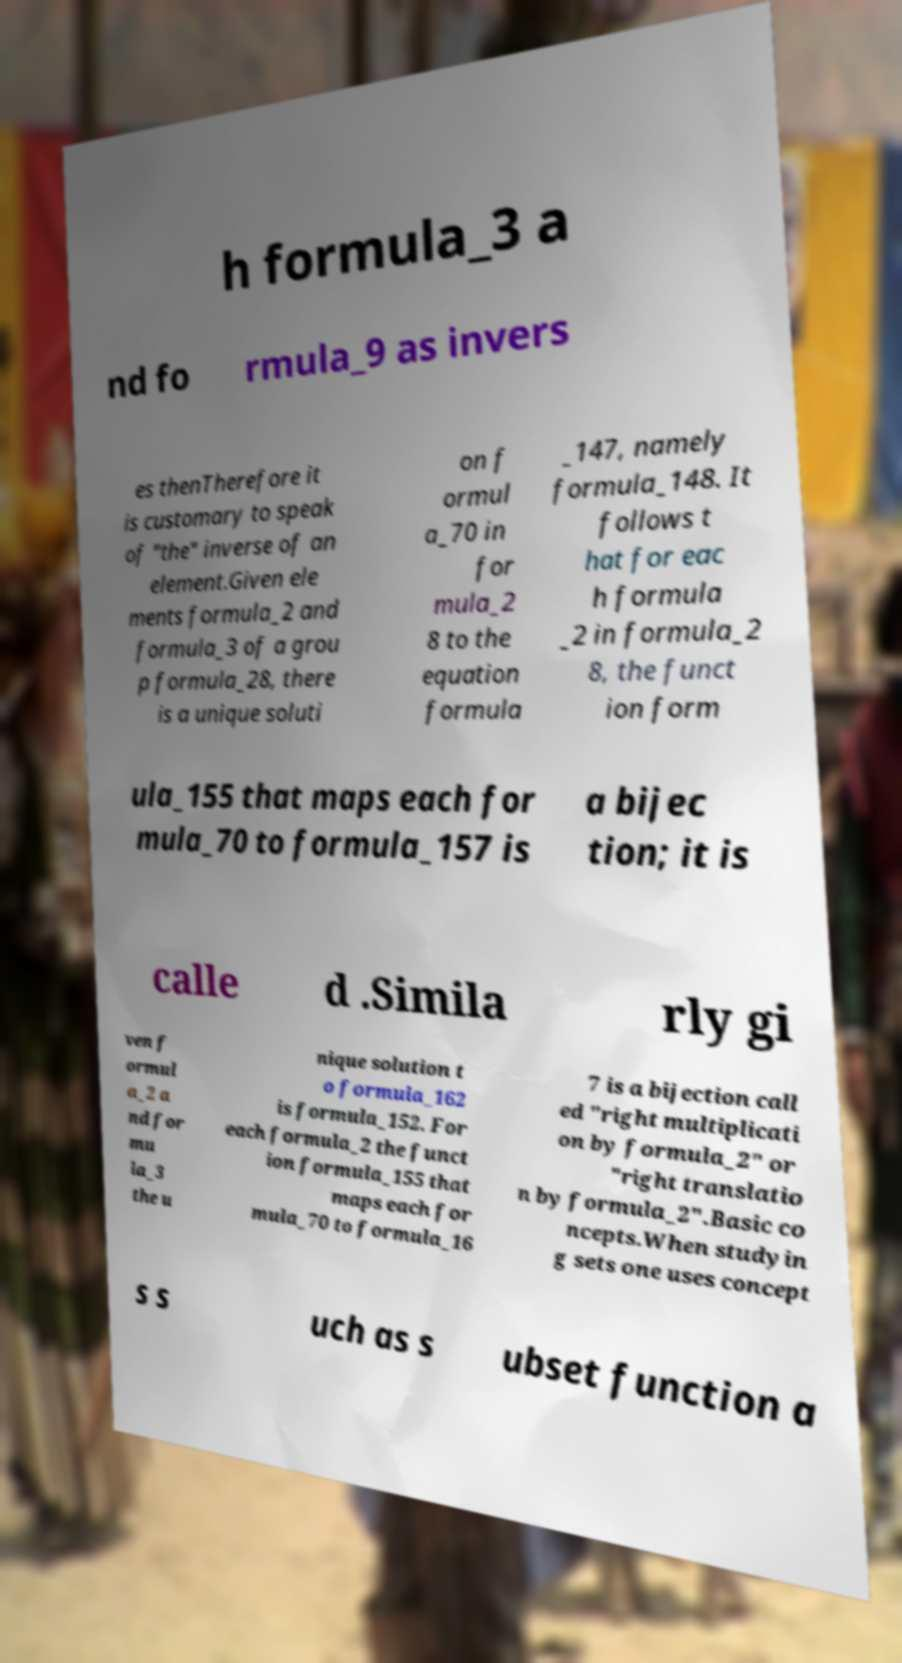I need the written content from this picture converted into text. Can you do that? h formula_3 a nd fo rmula_9 as invers es thenTherefore it is customary to speak of "the" inverse of an element.Given ele ments formula_2 and formula_3 of a grou p formula_28, there is a unique soluti on f ormul a_70 in for mula_2 8 to the equation formula _147, namely formula_148. It follows t hat for eac h formula _2 in formula_2 8, the funct ion form ula_155 that maps each for mula_70 to formula_157 is a bijec tion; it is calle d .Simila rly gi ven f ormul a_2 a nd for mu la_3 the u nique solution t o formula_162 is formula_152. For each formula_2 the funct ion formula_155 that maps each for mula_70 to formula_16 7 is a bijection call ed "right multiplicati on by formula_2" or "right translatio n by formula_2".Basic co ncepts.When studyin g sets one uses concept s s uch as s ubset function a 